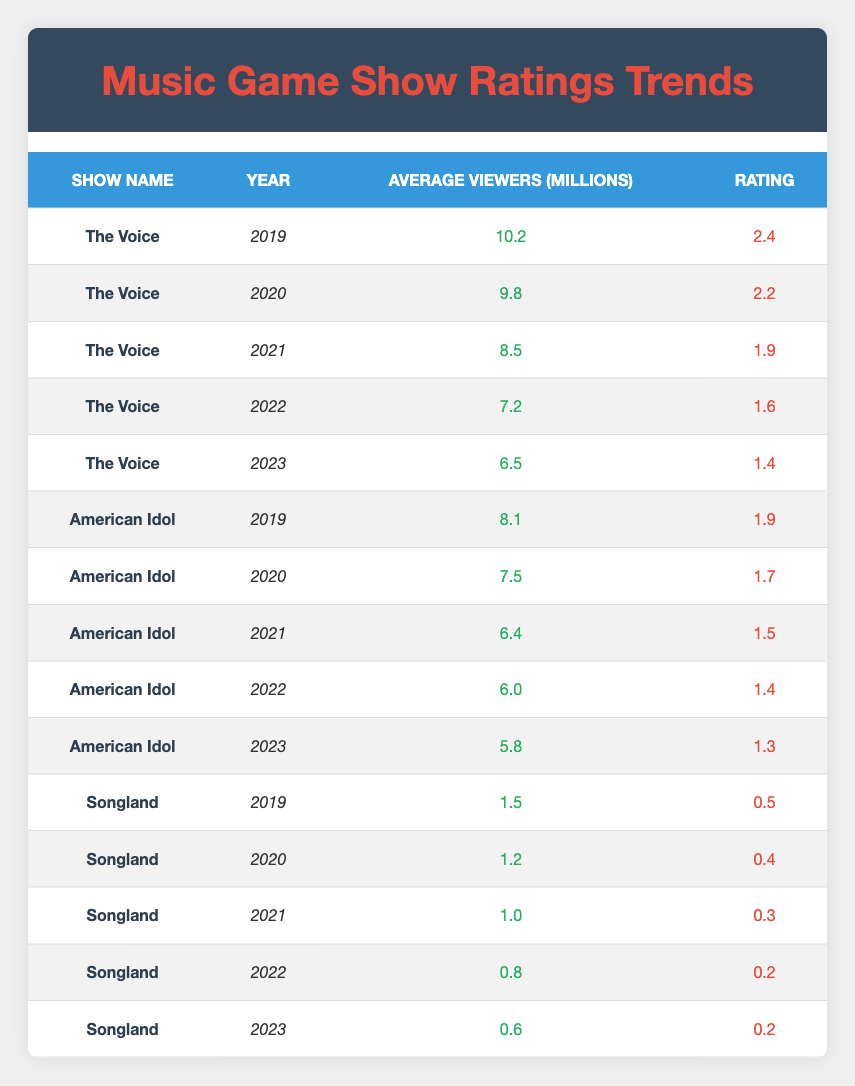What was the average viewer count for "The Voice" in 2021? In 2021, "The Voice" had an average of 8.5 million viewers, which can be found directly in the table under the corresponding row.
Answer: 8.5 million Which show had the highest rating in 2019? By checking the ratings for 2019 in the table, "The Voice" had the highest rating at 2.4 compared to "American Idol" at 1.9 and "Songland" at 0.5.
Answer: The Voice What is the difference in average viewers for "American Idol" between 2019 and 2023? The average viewers for "American Idol" in 2019 were 8.1 million, and in 2023 it was 5.8 million. The difference is 8.1 - 5.8 = 2.3 million.
Answer: 2.3 million Did "Songland" ever reach an average viewer count above 2 million? Review the viewer counts for "Songland" from 2019 to 2023; the highest was 1.5 million in 2019. Therefore, it never reached above 2 million.
Answer: No What is the overall trend in average viewership for "The Voice" over the five years? Analyzing the viewer counts for "The Voice" from 2019 (10.2 million) down to 2023 (6.5 million), it shows a continuous decline each year: 10.2, 9.8, 8.5, 7.2, and 6.5. This illustrates a consistent downward trend in average viewership.
Answer: Continuous decline What were the average viewers for "American Idol" in the middle year, and how does it compare to "The Voice" that year? In 2021, "American Idol" had 6.4 million average viewers and "The Voice" had 8.5 million. Comparing these, "The Voice" had 2.1 million more viewers than "American Idol" in 2021 (8.5 - 6.4).
Answer: 6.4 million; The Voice had 2.1 million more viewers Was there any year in which "Songland" had an increase in viewer count compared to the previous year? Reviewing the data for "Songland": 2019 (1.5), 2020 (1.2), 2021 (1.0), 2022 (0.8), and 2023 (0.6). Each year the viewer count decreased, indicating there were no increases at any point.
Answer: No What is the average rating for "American Idol" over the five years? To find the average rating, sum the ratings: (1.9 + 1.7 + 1.5 + 1.4 + 1.3) = 7.7, then divide by 5 (the number of years): 7.7 / 5 = 1.54.
Answer: 1.54 